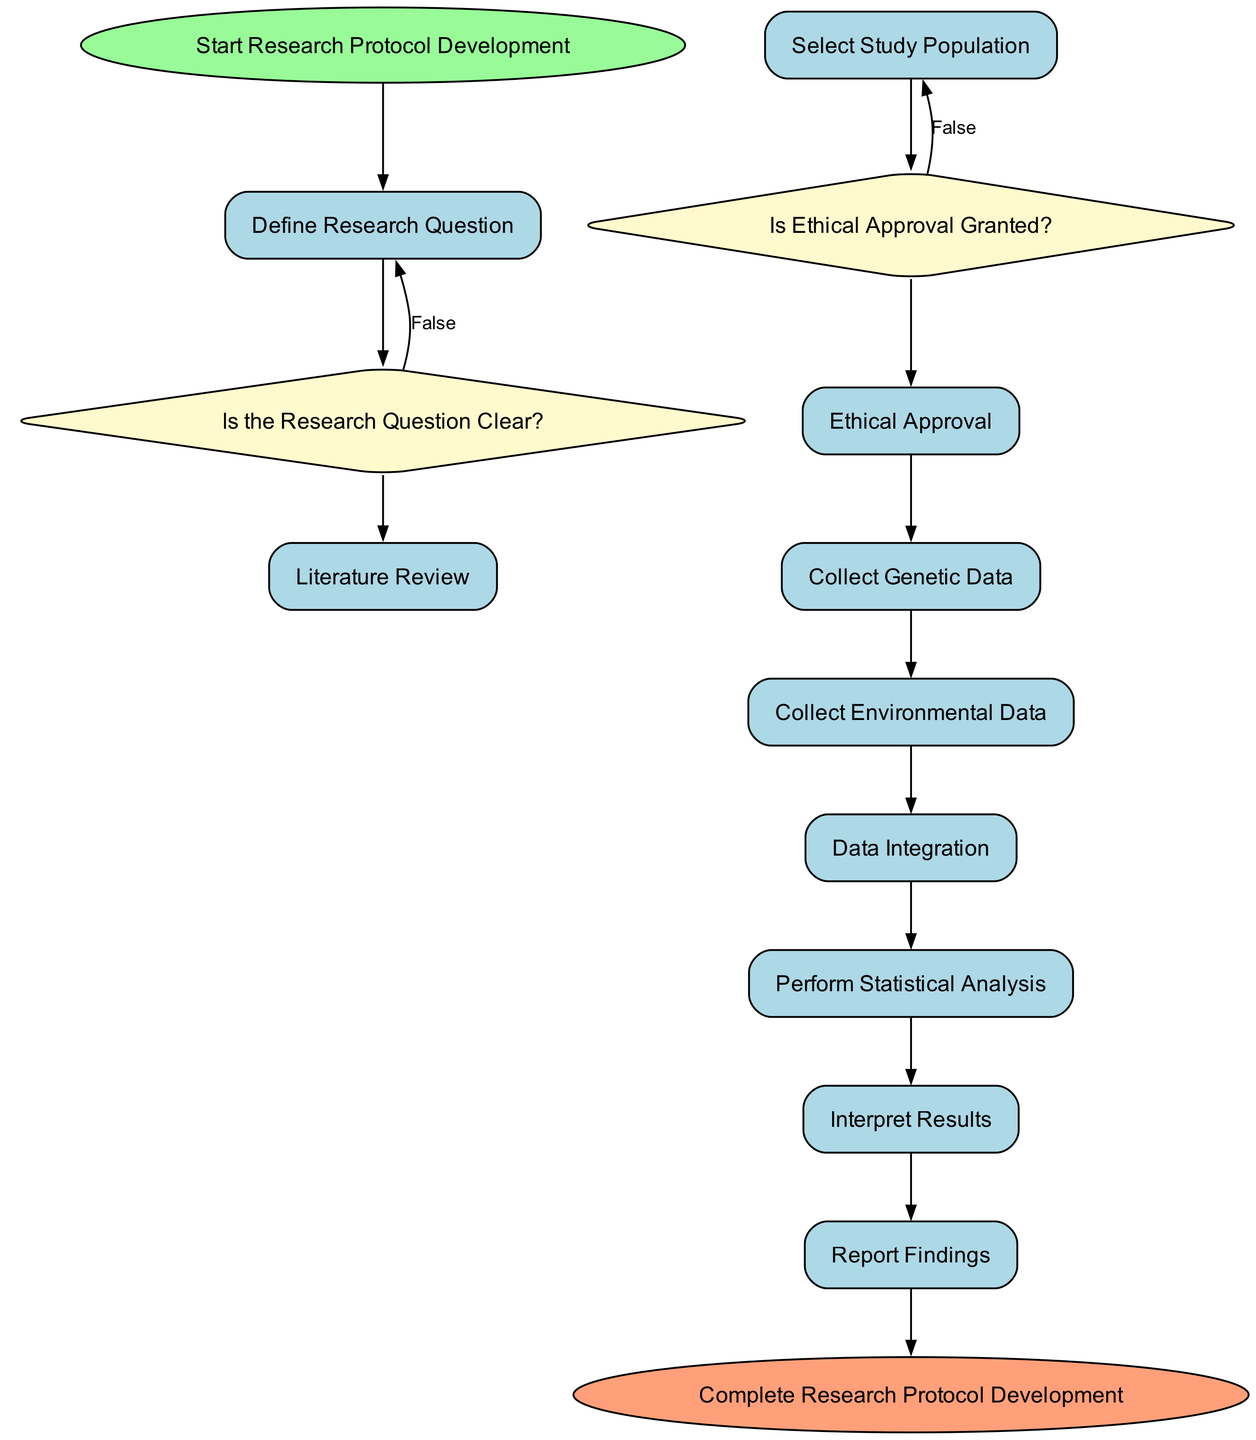What is the first activity in the research protocol? The first activity listed in the diagram is labeled "Define Research Question," which follows the initial start node.
Answer: Define Research Question How many decision nodes are present in the diagram? There are two decision nodes: "Is the Research Question Clear?" and "Is Ethical Approval Granted?" making a total of two.
Answer: 2 What is the final activity before completing the research protocol? The last activity before reaching the end node is "Report Findings," which is the final step before completion.
Answer: Report Findings What happens if the research question is not clear? If the research question is not clear, the process returns to the activity node "Define Research Question" based on the decision node outcomes.
Answer: Return to Define Research Question Which activity comes directly after collecting genetic data? After the activity "Collect Genetic Data," the next activity is "Collect Environmental Data," indicating a sequential process.
Answer: Collect Environmental Data What type of data is collected from study participants? The diagram indicates that "Genetic Data" is collected from study participants through methods such as saliva or blood samples.
Answer: Genetic Data In the sequence, what decision follows the selection of the study population? Once the study population is selected, a decision regarding whether ethical approval has been granted occurs next in the sequence.
Answer: Ethical Approval Decision What relationship exists between collecting genetic data and collecting environmental data? The two activities are sequentially related; environmental data collection follows after the collection of genetic data in the diagram workflow.
Answer: Sequential relationship What is the outcome of obtaining ethical approval? If ethical approval is granted, the flow continues to the activity "Collect Genetic Data," indicating a progression in the research protocol.
Answer: Proceed to Collect Genetic Data 